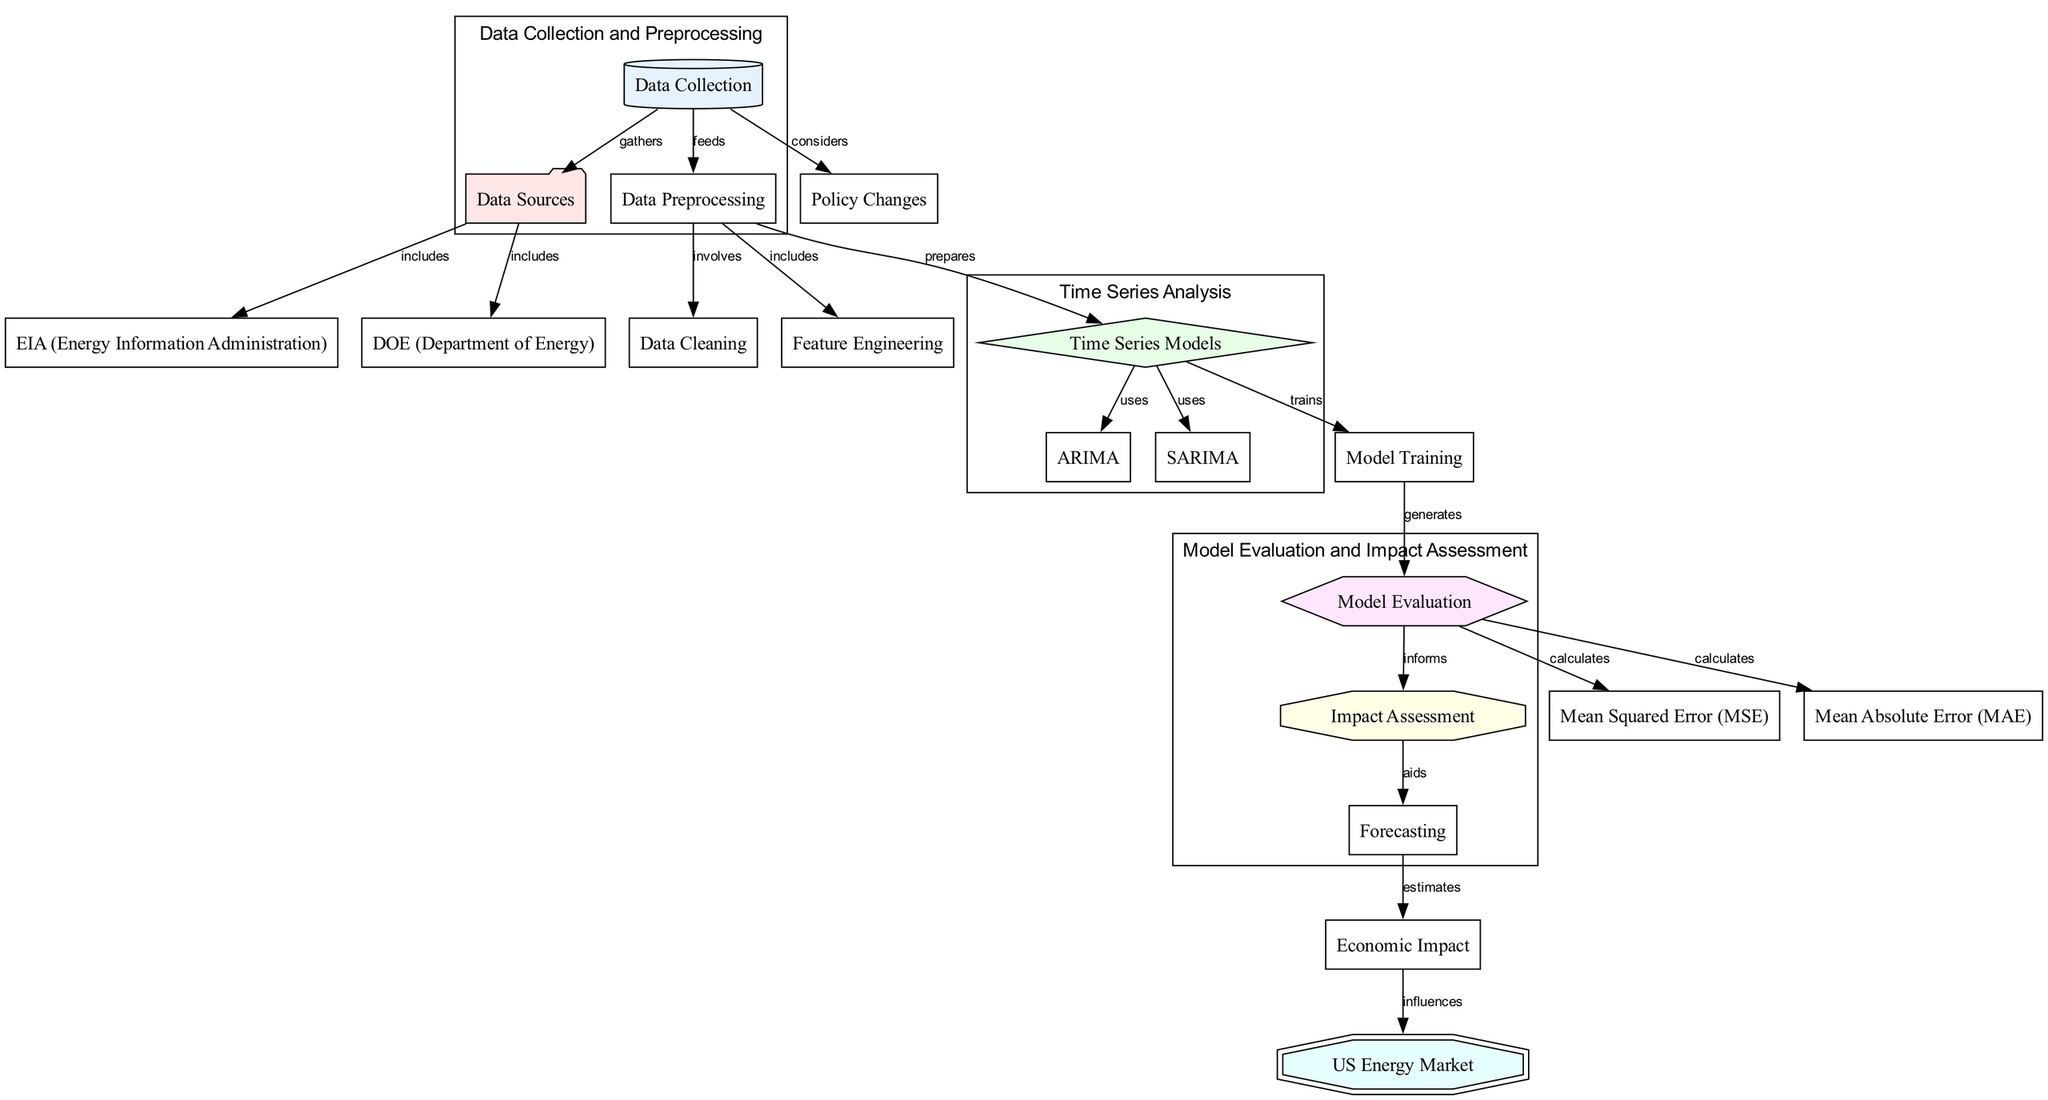What is the starting node of the diagram? The starting node is "Data Collection," which is placed at the top of the diagram as the initial step in the process.
Answer: Data Collection How many nodes are in the diagram? By counting the unique nodes listed, there are a total of 17 nodes in the diagram.
Answer: 17 Which node is linked directly to "Model Evaluation"? The node linked directly to "Model Evaluation" is "Model Training," as indicated by a direct edge leading to it.
Answer: Model Training What does "Impact Assessment" aid in? "Impact Assessment" aids in "Forecasting," as shown by the directed edge connecting the two nodes in the diagram.
Answer: Forecasting Which two nodes are grouped under "Time Series Analysis"? The two nodes grouped under "Time Series Analysis" are "ARIMA" and "SARIMA," which are both techniques used in time series modeling.
Answer: ARIMA, SARIMA What type of relationship exists between "Economic Impact" and "US Energy Market"? The relationship is one of influence; "Economic Impact" influences "US Energy Market," indicated by a directed edge from the former to the latter.
Answer: Influences What processes are included in "Data Preprocessing"? "Data Preprocessing" includes "Data Cleaning" and "Feature Engineering," as indicated by the directed edges emerging from the "Data Preprocessing" node.
Answer: Data Cleaning, Feature Engineering How does "Model Evaluation" connect to "Mean Absolute Error"? "Model Evaluation" directly calculates "Mean Absolute Error," as shown by the directed edge from "Model Evaluation" to "Mean Absolute Error."
Answer: Calculates What does "Forecasting" estimate? "Forecasting" estimates "Economic Impact," as indicated by the directed edge from "Forecasting" to "Economic Impact" in the diagram.
Answer: Economic Impact 